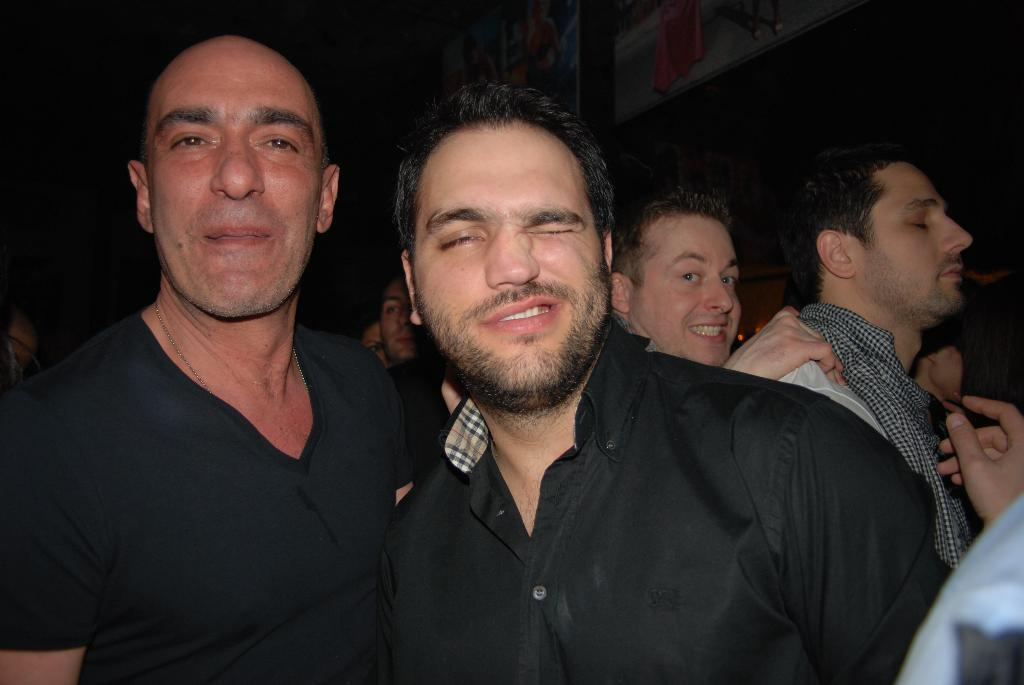How many people are in the image? There are many people in the image. Can you describe the appearance of two persons in the foreground? In the foreground, there are two persons wearing black shirts. What is the color of the background in the image? The background of the image is dark. How many sticks are being held by the pig in the image? There is no pig present in the image, and therefore no sticks are being held. 